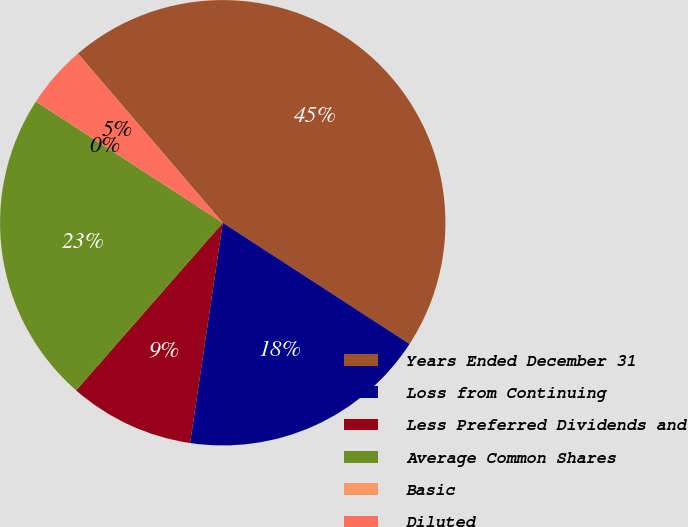Convert chart to OTSL. <chart><loc_0><loc_0><loc_500><loc_500><pie_chart><fcel>Years Ended December 31<fcel>Loss from Continuing<fcel>Less Preferred Dividends and<fcel>Average Common Shares<fcel>Basic<fcel>Diluted<nl><fcel>45.43%<fcel>18.18%<fcel>9.1%<fcel>22.72%<fcel>0.01%<fcel>4.56%<nl></chart> 